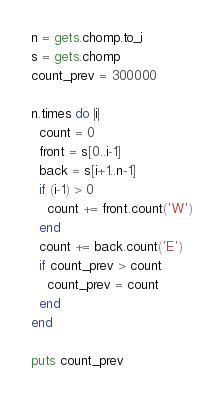<code> <loc_0><loc_0><loc_500><loc_500><_Ruby_>n = gets.chomp.to_i
s = gets.chomp
count_prev = 300000

n.times do |i|
  count = 0
  front = s[0..i-1]
  back = s[i+1..n-1]
  if (i-1) > 0
    count += front.count('W')
  end
  count += back.count('E')
  if count_prev > count
    count_prev = count
  end
end

puts count_prev
</code> 